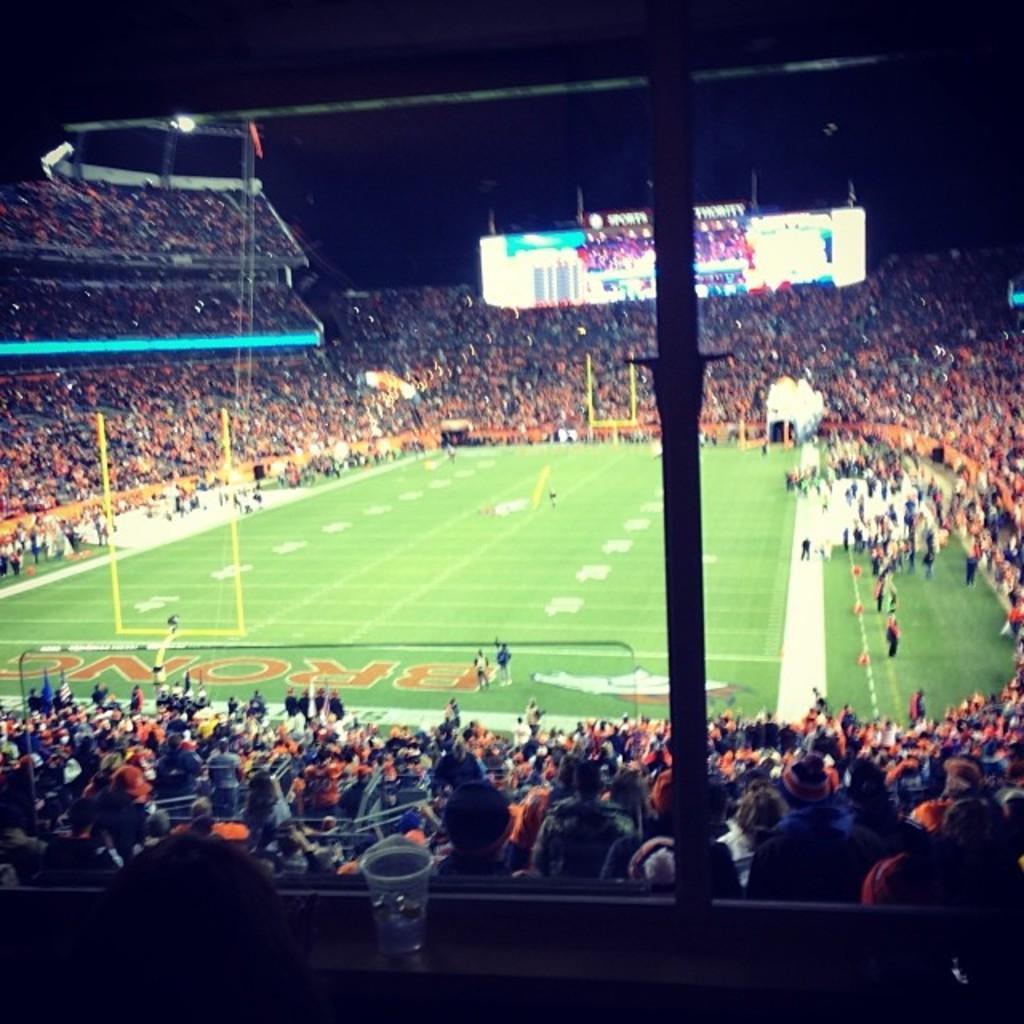Describe this image in one or two sentences. In this image there are few people on the ground and in the stands, there are goal posts, display screen and some marks on the ground. 